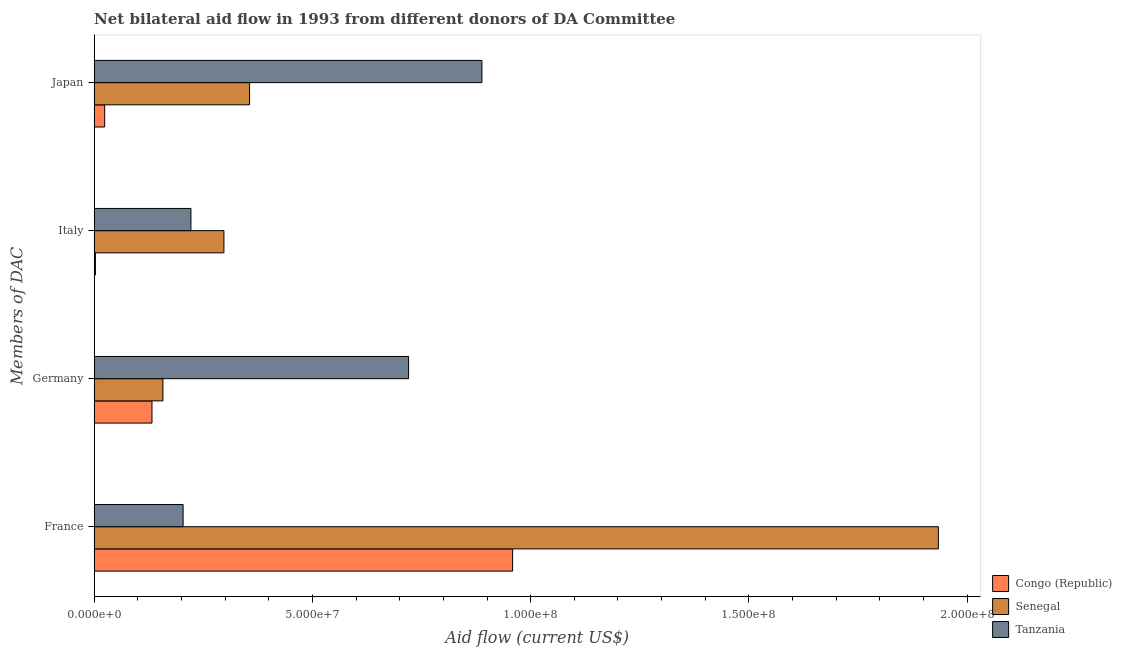How many different coloured bars are there?
Keep it short and to the point. 3. How many groups of bars are there?
Offer a very short reply. 4. What is the amount of aid given by italy in Senegal?
Make the answer very short. 2.97e+07. Across all countries, what is the maximum amount of aid given by france?
Your answer should be compact. 1.93e+08. Across all countries, what is the minimum amount of aid given by japan?
Your response must be concise. 2.40e+06. In which country was the amount of aid given by france maximum?
Your response must be concise. Senegal. In which country was the amount of aid given by italy minimum?
Keep it short and to the point. Congo (Republic). What is the total amount of aid given by france in the graph?
Make the answer very short. 3.10e+08. What is the difference between the amount of aid given by france in Senegal and that in Tanzania?
Keep it short and to the point. 1.73e+08. What is the difference between the amount of aid given by japan in Tanzania and the amount of aid given by france in Senegal?
Offer a terse response. -1.05e+08. What is the average amount of aid given by germany per country?
Ensure brevity in your answer.  3.37e+07. What is the difference between the amount of aid given by italy and amount of aid given by france in Tanzania?
Your answer should be compact. 1.79e+06. In how many countries, is the amount of aid given by italy greater than 50000000 US$?
Ensure brevity in your answer.  0. What is the ratio of the amount of aid given by japan in Tanzania to that in Congo (Republic)?
Give a very brief answer. 37.01. Is the difference between the amount of aid given by italy in Senegal and Tanzania greater than the difference between the amount of aid given by france in Senegal and Tanzania?
Your answer should be very brief. No. What is the difference between the highest and the second highest amount of aid given by japan?
Offer a terse response. 5.32e+07. What is the difference between the highest and the lowest amount of aid given by japan?
Your response must be concise. 8.64e+07. In how many countries, is the amount of aid given by france greater than the average amount of aid given by france taken over all countries?
Ensure brevity in your answer.  1. Is the sum of the amount of aid given by italy in Congo (Republic) and Senegal greater than the maximum amount of aid given by japan across all countries?
Ensure brevity in your answer.  No. Is it the case that in every country, the sum of the amount of aid given by germany and amount of aid given by france is greater than the sum of amount of aid given by italy and amount of aid given by japan?
Keep it short and to the point. No. What does the 1st bar from the top in Japan represents?
Give a very brief answer. Tanzania. What does the 2nd bar from the bottom in Germany represents?
Give a very brief answer. Senegal. Is it the case that in every country, the sum of the amount of aid given by france and amount of aid given by germany is greater than the amount of aid given by italy?
Your answer should be compact. Yes. How many countries are there in the graph?
Your response must be concise. 3. Does the graph contain grids?
Offer a very short reply. No. How are the legend labels stacked?
Your answer should be very brief. Vertical. What is the title of the graph?
Your response must be concise. Net bilateral aid flow in 1993 from different donors of DA Committee. What is the label or title of the Y-axis?
Your response must be concise. Members of DAC. What is the Aid flow (current US$) of Congo (Republic) in France?
Keep it short and to the point. 9.59e+07. What is the Aid flow (current US$) in Senegal in France?
Give a very brief answer. 1.93e+08. What is the Aid flow (current US$) of Tanzania in France?
Offer a very short reply. 2.04e+07. What is the Aid flow (current US$) in Congo (Republic) in Germany?
Keep it short and to the point. 1.32e+07. What is the Aid flow (current US$) in Senegal in Germany?
Your answer should be compact. 1.58e+07. What is the Aid flow (current US$) of Tanzania in Germany?
Make the answer very short. 7.20e+07. What is the Aid flow (current US$) of Congo (Republic) in Italy?
Provide a succinct answer. 2.80e+05. What is the Aid flow (current US$) in Senegal in Italy?
Provide a succinct answer. 2.97e+07. What is the Aid flow (current US$) of Tanzania in Italy?
Give a very brief answer. 2.22e+07. What is the Aid flow (current US$) of Congo (Republic) in Japan?
Ensure brevity in your answer.  2.40e+06. What is the Aid flow (current US$) in Senegal in Japan?
Your answer should be very brief. 3.56e+07. What is the Aid flow (current US$) of Tanzania in Japan?
Your response must be concise. 8.88e+07. Across all Members of DAC, what is the maximum Aid flow (current US$) of Congo (Republic)?
Your answer should be very brief. 9.59e+07. Across all Members of DAC, what is the maximum Aid flow (current US$) in Senegal?
Your response must be concise. 1.93e+08. Across all Members of DAC, what is the maximum Aid flow (current US$) in Tanzania?
Your answer should be compact. 8.88e+07. Across all Members of DAC, what is the minimum Aid flow (current US$) in Congo (Republic)?
Offer a terse response. 2.80e+05. Across all Members of DAC, what is the minimum Aid flow (current US$) in Senegal?
Your answer should be very brief. 1.58e+07. Across all Members of DAC, what is the minimum Aid flow (current US$) in Tanzania?
Keep it short and to the point. 2.04e+07. What is the total Aid flow (current US$) of Congo (Republic) in the graph?
Provide a succinct answer. 1.12e+08. What is the total Aid flow (current US$) in Senegal in the graph?
Provide a succinct answer. 2.74e+08. What is the total Aid flow (current US$) of Tanzania in the graph?
Provide a succinct answer. 2.03e+08. What is the difference between the Aid flow (current US$) in Congo (Republic) in France and that in Germany?
Make the answer very short. 8.26e+07. What is the difference between the Aid flow (current US$) of Senegal in France and that in Germany?
Your answer should be very brief. 1.78e+08. What is the difference between the Aid flow (current US$) in Tanzania in France and that in Germany?
Your answer should be compact. -5.17e+07. What is the difference between the Aid flow (current US$) in Congo (Republic) in France and that in Italy?
Ensure brevity in your answer.  9.56e+07. What is the difference between the Aid flow (current US$) of Senegal in France and that in Italy?
Provide a short and direct response. 1.64e+08. What is the difference between the Aid flow (current US$) of Tanzania in France and that in Italy?
Your answer should be very brief. -1.79e+06. What is the difference between the Aid flow (current US$) of Congo (Republic) in France and that in Japan?
Provide a short and direct response. 9.35e+07. What is the difference between the Aid flow (current US$) of Senegal in France and that in Japan?
Your answer should be compact. 1.58e+08. What is the difference between the Aid flow (current US$) of Tanzania in France and that in Japan?
Provide a succinct answer. -6.85e+07. What is the difference between the Aid flow (current US$) of Congo (Republic) in Germany and that in Italy?
Offer a terse response. 1.30e+07. What is the difference between the Aid flow (current US$) in Senegal in Germany and that in Italy?
Provide a succinct answer. -1.40e+07. What is the difference between the Aid flow (current US$) of Tanzania in Germany and that in Italy?
Provide a succinct answer. 4.99e+07. What is the difference between the Aid flow (current US$) of Congo (Republic) in Germany and that in Japan?
Provide a succinct answer. 1.08e+07. What is the difference between the Aid flow (current US$) of Senegal in Germany and that in Japan?
Provide a succinct answer. -1.98e+07. What is the difference between the Aid flow (current US$) of Tanzania in Germany and that in Japan?
Give a very brief answer. -1.68e+07. What is the difference between the Aid flow (current US$) in Congo (Republic) in Italy and that in Japan?
Offer a very short reply. -2.12e+06. What is the difference between the Aid flow (current US$) in Senegal in Italy and that in Japan?
Provide a short and direct response. -5.88e+06. What is the difference between the Aid flow (current US$) in Tanzania in Italy and that in Japan?
Provide a short and direct response. -6.67e+07. What is the difference between the Aid flow (current US$) in Congo (Republic) in France and the Aid flow (current US$) in Senegal in Germany?
Provide a succinct answer. 8.01e+07. What is the difference between the Aid flow (current US$) of Congo (Republic) in France and the Aid flow (current US$) of Tanzania in Germany?
Provide a succinct answer. 2.38e+07. What is the difference between the Aid flow (current US$) in Senegal in France and the Aid flow (current US$) in Tanzania in Germany?
Give a very brief answer. 1.21e+08. What is the difference between the Aid flow (current US$) of Congo (Republic) in France and the Aid flow (current US$) of Senegal in Italy?
Give a very brief answer. 6.61e+07. What is the difference between the Aid flow (current US$) of Congo (Republic) in France and the Aid flow (current US$) of Tanzania in Italy?
Your answer should be very brief. 7.37e+07. What is the difference between the Aid flow (current US$) of Senegal in France and the Aid flow (current US$) of Tanzania in Italy?
Your answer should be compact. 1.71e+08. What is the difference between the Aid flow (current US$) of Congo (Republic) in France and the Aid flow (current US$) of Senegal in Japan?
Provide a short and direct response. 6.03e+07. What is the difference between the Aid flow (current US$) in Congo (Republic) in France and the Aid flow (current US$) in Tanzania in Japan?
Make the answer very short. 7.03e+06. What is the difference between the Aid flow (current US$) in Senegal in France and the Aid flow (current US$) in Tanzania in Japan?
Provide a succinct answer. 1.05e+08. What is the difference between the Aid flow (current US$) of Congo (Republic) in Germany and the Aid flow (current US$) of Senegal in Italy?
Offer a very short reply. -1.65e+07. What is the difference between the Aid flow (current US$) of Congo (Republic) in Germany and the Aid flow (current US$) of Tanzania in Italy?
Make the answer very short. -8.92e+06. What is the difference between the Aid flow (current US$) in Senegal in Germany and the Aid flow (current US$) in Tanzania in Italy?
Keep it short and to the point. -6.41e+06. What is the difference between the Aid flow (current US$) in Congo (Republic) in Germany and the Aid flow (current US$) in Senegal in Japan?
Offer a terse response. -2.24e+07. What is the difference between the Aid flow (current US$) in Congo (Republic) in Germany and the Aid flow (current US$) in Tanzania in Japan?
Offer a very short reply. -7.56e+07. What is the difference between the Aid flow (current US$) of Senegal in Germany and the Aid flow (current US$) of Tanzania in Japan?
Make the answer very short. -7.31e+07. What is the difference between the Aid flow (current US$) in Congo (Republic) in Italy and the Aid flow (current US$) in Senegal in Japan?
Your answer should be compact. -3.53e+07. What is the difference between the Aid flow (current US$) of Congo (Republic) in Italy and the Aid flow (current US$) of Tanzania in Japan?
Your answer should be very brief. -8.86e+07. What is the difference between the Aid flow (current US$) of Senegal in Italy and the Aid flow (current US$) of Tanzania in Japan?
Ensure brevity in your answer.  -5.91e+07. What is the average Aid flow (current US$) in Congo (Republic) per Members of DAC?
Provide a short and direct response. 2.79e+07. What is the average Aid flow (current US$) of Senegal per Members of DAC?
Provide a short and direct response. 6.86e+07. What is the average Aid flow (current US$) of Tanzania per Members of DAC?
Ensure brevity in your answer.  5.08e+07. What is the difference between the Aid flow (current US$) of Congo (Republic) and Aid flow (current US$) of Senegal in France?
Your response must be concise. -9.76e+07. What is the difference between the Aid flow (current US$) in Congo (Republic) and Aid flow (current US$) in Tanzania in France?
Give a very brief answer. 7.55e+07. What is the difference between the Aid flow (current US$) in Senegal and Aid flow (current US$) in Tanzania in France?
Provide a succinct answer. 1.73e+08. What is the difference between the Aid flow (current US$) in Congo (Republic) and Aid flow (current US$) in Senegal in Germany?
Ensure brevity in your answer.  -2.51e+06. What is the difference between the Aid flow (current US$) of Congo (Republic) and Aid flow (current US$) of Tanzania in Germany?
Your answer should be very brief. -5.88e+07. What is the difference between the Aid flow (current US$) of Senegal and Aid flow (current US$) of Tanzania in Germany?
Offer a very short reply. -5.63e+07. What is the difference between the Aid flow (current US$) in Congo (Republic) and Aid flow (current US$) in Senegal in Italy?
Your answer should be very brief. -2.94e+07. What is the difference between the Aid flow (current US$) in Congo (Republic) and Aid flow (current US$) in Tanzania in Italy?
Offer a very short reply. -2.19e+07. What is the difference between the Aid flow (current US$) in Senegal and Aid flow (current US$) in Tanzania in Italy?
Provide a short and direct response. 7.56e+06. What is the difference between the Aid flow (current US$) in Congo (Republic) and Aid flow (current US$) in Senegal in Japan?
Make the answer very short. -3.32e+07. What is the difference between the Aid flow (current US$) of Congo (Republic) and Aid flow (current US$) of Tanzania in Japan?
Provide a succinct answer. -8.64e+07. What is the difference between the Aid flow (current US$) of Senegal and Aid flow (current US$) of Tanzania in Japan?
Offer a terse response. -5.32e+07. What is the ratio of the Aid flow (current US$) of Congo (Republic) in France to that in Germany?
Give a very brief answer. 7.24. What is the ratio of the Aid flow (current US$) in Senegal in France to that in Germany?
Keep it short and to the point. 12.28. What is the ratio of the Aid flow (current US$) in Tanzania in France to that in Germany?
Your answer should be very brief. 0.28. What is the ratio of the Aid flow (current US$) of Congo (Republic) in France to that in Italy?
Provide a succinct answer. 342.36. What is the ratio of the Aid flow (current US$) of Senegal in France to that in Italy?
Provide a succinct answer. 6.51. What is the ratio of the Aid flow (current US$) in Tanzania in France to that in Italy?
Offer a very short reply. 0.92. What is the ratio of the Aid flow (current US$) of Congo (Republic) in France to that in Japan?
Keep it short and to the point. 39.94. What is the ratio of the Aid flow (current US$) of Senegal in France to that in Japan?
Your response must be concise. 5.43. What is the ratio of the Aid flow (current US$) in Tanzania in France to that in Japan?
Ensure brevity in your answer.  0.23. What is the ratio of the Aid flow (current US$) of Congo (Republic) in Germany to that in Italy?
Your answer should be compact. 47.29. What is the ratio of the Aid flow (current US$) of Senegal in Germany to that in Italy?
Ensure brevity in your answer.  0.53. What is the ratio of the Aid flow (current US$) of Tanzania in Germany to that in Italy?
Make the answer very short. 3.25. What is the ratio of the Aid flow (current US$) of Congo (Republic) in Germany to that in Japan?
Your response must be concise. 5.52. What is the ratio of the Aid flow (current US$) of Senegal in Germany to that in Japan?
Your answer should be compact. 0.44. What is the ratio of the Aid flow (current US$) in Tanzania in Germany to that in Japan?
Your answer should be compact. 0.81. What is the ratio of the Aid flow (current US$) in Congo (Republic) in Italy to that in Japan?
Keep it short and to the point. 0.12. What is the ratio of the Aid flow (current US$) in Senegal in Italy to that in Japan?
Provide a succinct answer. 0.83. What is the ratio of the Aid flow (current US$) in Tanzania in Italy to that in Japan?
Provide a succinct answer. 0.25. What is the difference between the highest and the second highest Aid flow (current US$) in Congo (Republic)?
Your answer should be very brief. 8.26e+07. What is the difference between the highest and the second highest Aid flow (current US$) of Senegal?
Provide a succinct answer. 1.58e+08. What is the difference between the highest and the second highest Aid flow (current US$) in Tanzania?
Offer a terse response. 1.68e+07. What is the difference between the highest and the lowest Aid flow (current US$) in Congo (Republic)?
Keep it short and to the point. 9.56e+07. What is the difference between the highest and the lowest Aid flow (current US$) in Senegal?
Offer a terse response. 1.78e+08. What is the difference between the highest and the lowest Aid flow (current US$) of Tanzania?
Your answer should be compact. 6.85e+07. 